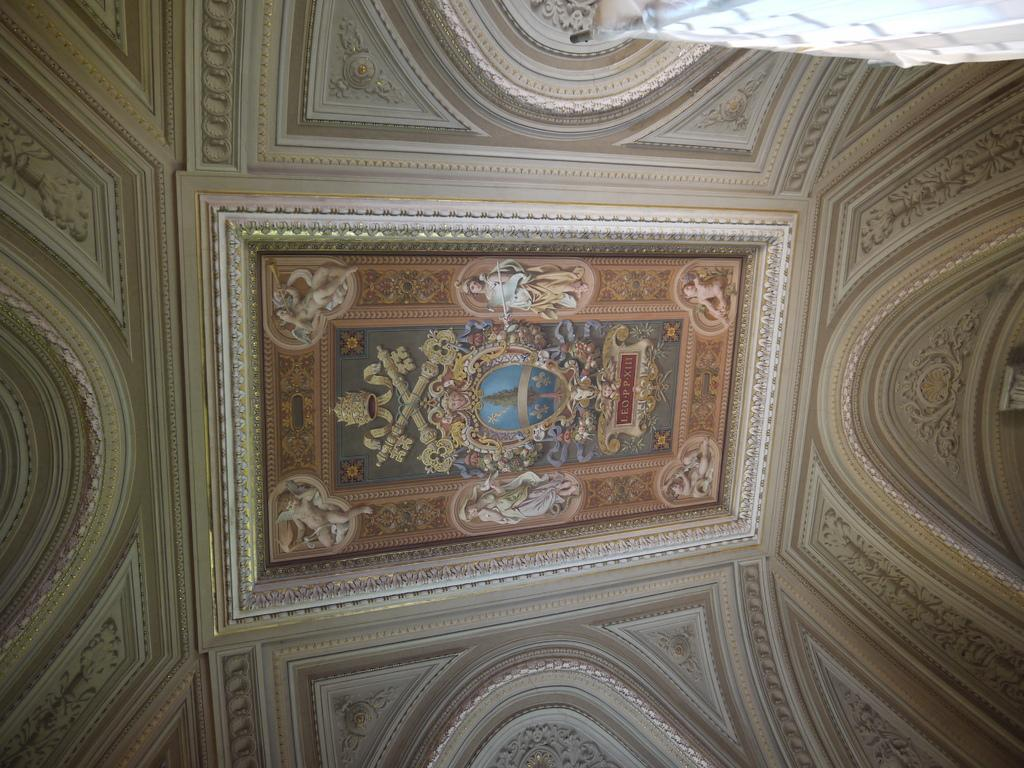What part of a room or building is shown in the image? The image appears to depict a ceiling. What can be seen on the ceiling in the image? There are pictures of persons and a tree in the middle of the ceiling. What type of bread is being used to decorate the tree on the ceiling? There is no bread present in the image; it only features pictures of persons and a tree on the ceiling. 